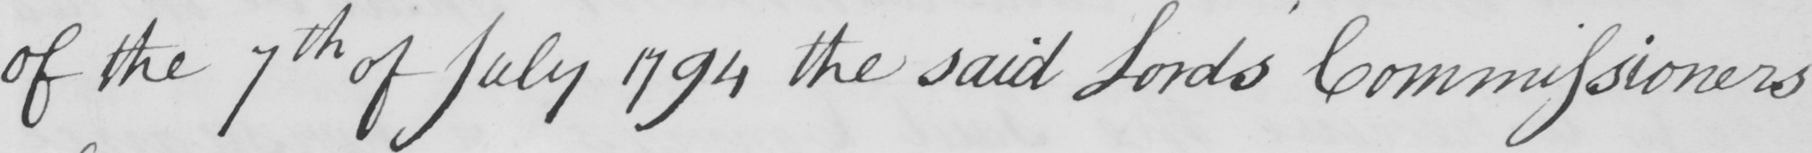What is written in this line of handwriting? of the 7th of July 1794 the said Lord ' s Commissioners 